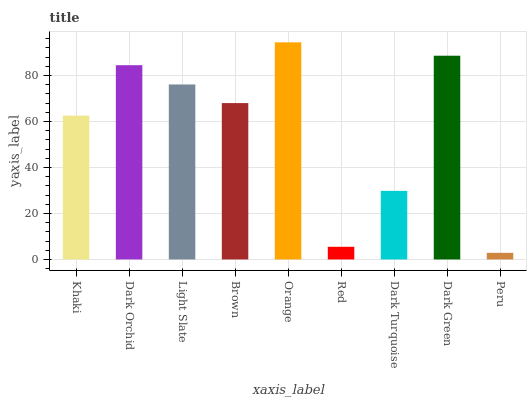Is Peru the minimum?
Answer yes or no. Yes. Is Orange the maximum?
Answer yes or no. Yes. Is Dark Orchid the minimum?
Answer yes or no. No. Is Dark Orchid the maximum?
Answer yes or no. No. Is Dark Orchid greater than Khaki?
Answer yes or no. Yes. Is Khaki less than Dark Orchid?
Answer yes or no. Yes. Is Khaki greater than Dark Orchid?
Answer yes or no. No. Is Dark Orchid less than Khaki?
Answer yes or no. No. Is Brown the high median?
Answer yes or no. Yes. Is Brown the low median?
Answer yes or no. Yes. Is Orange the high median?
Answer yes or no. No. Is Light Slate the low median?
Answer yes or no. No. 